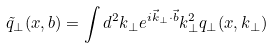Convert formula to latex. <formula><loc_0><loc_0><loc_500><loc_500>\tilde { q } _ { \perp } ( x , b ) = \int d ^ { 2 } k _ { \perp } e ^ { i \vec { k } _ { \perp } \cdot \vec { b } } k ^ { 2 } _ { \perp } q _ { \perp } ( x , k _ { \perp } )</formula> 